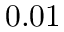<formula> <loc_0><loc_0><loc_500><loc_500>0 . 0 1</formula> 